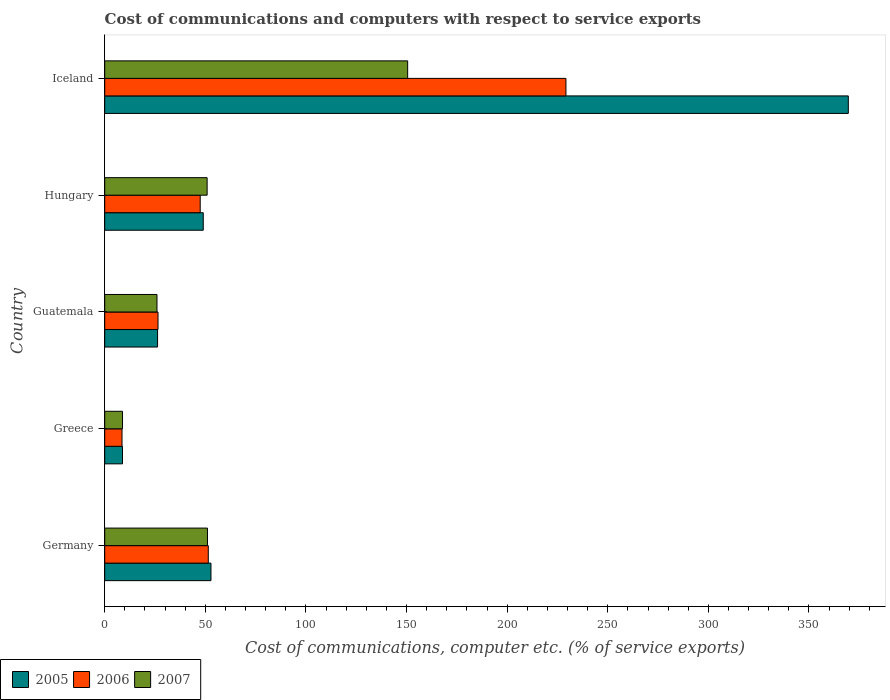How many different coloured bars are there?
Offer a very short reply. 3. Are the number of bars per tick equal to the number of legend labels?
Give a very brief answer. Yes. Are the number of bars on each tick of the Y-axis equal?
Provide a succinct answer. Yes. How many bars are there on the 2nd tick from the top?
Make the answer very short. 3. How many bars are there on the 5th tick from the bottom?
Make the answer very short. 3. What is the label of the 5th group of bars from the top?
Offer a terse response. Germany. What is the cost of communications and computers in 2007 in Guatemala?
Offer a terse response. 25.98. Across all countries, what is the maximum cost of communications and computers in 2007?
Your answer should be compact. 150.55. Across all countries, what is the minimum cost of communications and computers in 2005?
Keep it short and to the point. 8.84. In which country was the cost of communications and computers in 2006 maximum?
Your answer should be compact. Iceland. In which country was the cost of communications and computers in 2007 minimum?
Offer a terse response. Greece. What is the total cost of communications and computers in 2006 in the graph?
Provide a short and direct response. 363.22. What is the difference between the cost of communications and computers in 2005 in Guatemala and that in Iceland?
Give a very brief answer. -343.28. What is the difference between the cost of communications and computers in 2007 in Guatemala and the cost of communications and computers in 2006 in Germany?
Provide a short and direct response. -25.49. What is the average cost of communications and computers in 2006 per country?
Your answer should be compact. 72.64. What is the difference between the cost of communications and computers in 2005 and cost of communications and computers in 2006 in Hungary?
Ensure brevity in your answer.  1.51. What is the ratio of the cost of communications and computers in 2006 in Guatemala to that in Hungary?
Your answer should be very brief. 0.56. Is the cost of communications and computers in 2006 in Germany less than that in Hungary?
Your response must be concise. No. What is the difference between the highest and the second highest cost of communications and computers in 2007?
Provide a succinct answer. 99.49. What is the difference between the highest and the lowest cost of communications and computers in 2006?
Provide a short and direct response. 220.61. In how many countries, is the cost of communications and computers in 2007 greater than the average cost of communications and computers in 2007 taken over all countries?
Make the answer very short. 1. Is it the case that in every country, the sum of the cost of communications and computers in 2005 and cost of communications and computers in 2007 is greater than the cost of communications and computers in 2006?
Offer a terse response. Yes. How many bars are there?
Provide a succinct answer. 15. Are the values on the major ticks of X-axis written in scientific E-notation?
Offer a terse response. No. Does the graph contain grids?
Your response must be concise. No. Where does the legend appear in the graph?
Give a very brief answer. Bottom left. How many legend labels are there?
Provide a short and direct response. 3. What is the title of the graph?
Your answer should be very brief. Cost of communications and computers with respect to service exports. Does "1967" appear as one of the legend labels in the graph?
Keep it short and to the point. No. What is the label or title of the X-axis?
Your answer should be compact. Cost of communications, computer etc. (% of service exports). What is the label or title of the Y-axis?
Keep it short and to the point. Country. What is the Cost of communications, computer etc. (% of service exports) of 2005 in Germany?
Your response must be concise. 52.8. What is the Cost of communications, computer etc. (% of service exports) of 2006 in Germany?
Your answer should be compact. 51.47. What is the Cost of communications, computer etc. (% of service exports) in 2007 in Germany?
Make the answer very short. 51.06. What is the Cost of communications, computer etc. (% of service exports) in 2005 in Greece?
Your answer should be compact. 8.84. What is the Cost of communications, computer etc. (% of service exports) of 2006 in Greece?
Provide a short and direct response. 8.6. What is the Cost of communications, computer etc. (% of service exports) in 2007 in Greece?
Give a very brief answer. 8.84. What is the Cost of communications, computer etc. (% of service exports) in 2005 in Guatemala?
Offer a very short reply. 26.27. What is the Cost of communications, computer etc. (% of service exports) of 2006 in Guatemala?
Offer a very short reply. 26.49. What is the Cost of communications, computer etc. (% of service exports) of 2007 in Guatemala?
Provide a short and direct response. 25.98. What is the Cost of communications, computer etc. (% of service exports) of 2005 in Hungary?
Give a very brief answer. 48.97. What is the Cost of communications, computer etc. (% of service exports) in 2006 in Hungary?
Your response must be concise. 47.45. What is the Cost of communications, computer etc. (% of service exports) in 2007 in Hungary?
Your response must be concise. 50.89. What is the Cost of communications, computer etc. (% of service exports) in 2005 in Iceland?
Make the answer very short. 369.54. What is the Cost of communications, computer etc. (% of service exports) in 2006 in Iceland?
Provide a short and direct response. 229.21. What is the Cost of communications, computer etc. (% of service exports) of 2007 in Iceland?
Keep it short and to the point. 150.55. Across all countries, what is the maximum Cost of communications, computer etc. (% of service exports) of 2005?
Give a very brief answer. 369.54. Across all countries, what is the maximum Cost of communications, computer etc. (% of service exports) in 2006?
Give a very brief answer. 229.21. Across all countries, what is the maximum Cost of communications, computer etc. (% of service exports) of 2007?
Your answer should be very brief. 150.55. Across all countries, what is the minimum Cost of communications, computer etc. (% of service exports) in 2005?
Your response must be concise. 8.84. Across all countries, what is the minimum Cost of communications, computer etc. (% of service exports) in 2006?
Offer a very short reply. 8.6. Across all countries, what is the minimum Cost of communications, computer etc. (% of service exports) of 2007?
Give a very brief answer. 8.84. What is the total Cost of communications, computer etc. (% of service exports) of 2005 in the graph?
Keep it short and to the point. 506.42. What is the total Cost of communications, computer etc. (% of service exports) of 2006 in the graph?
Make the answer very short. 363.22. What is the total Cost of communications, computer etc. (% of service exports) of 2007 in the graph?
Your answer should be very brief. 287.32. What is the difference between the Cost of communications, computer etc. (% of service exports) in 2005 in Germany and that in Greece?
Make the answer very short. 43.96. What is the difference between the Cost of communications, computer etc. (% of service exports) in 2006 in Germany and that in Greece?
Offer a very short reply. 42.87. What is the difference between the Cost of communications, computer etc. (% of service exports) in 2007 in Germany and that in Greece?
Your answer should be very brief. 42.22. What is the difference between the Cost of communications, computer etc. (% of service exports) of 2005 in Germany and that in Guatemala?
Offer a terse response. 26.54. What is the difference between the Cost of communications, computer etc. (% of service exports) in 2006 in Germany and that in Guatemala?
Offer a very short reply. 24.98. What is the difference between the Cost of communications, computer etc. (% of service exports) of 2007 in Germany and that in Guatemala?
Ensure brevity in your answer.  25.09. What is the difference between the Cost of communications, computer etc. (% of service exports) of 2005 in Germany and that in Hungary?
Your answer should be very brief. 3.84. What is the difference between the Cost of communications, computer etc. (% of service exports) of 2006 in Germany and that in Hungary?
Give a very brief answer. 4.01. What is the difference between the Cost of communications, computer etc. (% of service exports) in 2007 in Germany and that in Hungary?
Provide a succinct answer. 0.17. What is the difference between the Cost of communications, computer etc. (% of service exports) in 2005 in Germany and that in Iceland?
Your response must be concise. -316.74. What is the difference between the Cost of communications, computer etc. (% of service exports) of 2006 in Germany and that in Iceland?
Your answer should be very brief. -177.74. What is the difference between the Cost of communications, computer etc. (% of service exports) of 2007 in Germany and that in Iceland?
Offer a very short reply. -99.49. What is the difference between the Cost of communications, computer etc. (% of service exports) in 2005 in Greece and that in Guatemala?
Provide a short and direct response. -17.42. What is the difference between the Cost of communications, computer etc. (% of service exports) of 2006 in Greece and that in Guatemala?
Give a very brief answer. -17.89. What is the difference between the Cost of communications, computer etc. (% of service exports) of 2007 in Greece and that in Guatemala?
Your answer should be very brief. -17.13. What is the difference between the Cost of communications, computer etc. (% of service exports) of 2005 in Greece and that in Hungary?
Your answer should be compact. -40.13. What is the difference between the Cost of communications, computer etc. (% of service exports) of 2006 in Greece and that in Hungary?
Provide a short and direct response. -38.86. What is the difference between the Cost of communications, computer etc. (% of service exports) in 2007 in Greece and that in Hungary?
Offer a terse response. -42.05. What is the difference between the Cost of communications, computer etc. (% of service exports) of 2005 in Greece and that in Iceland?
Keep it short and to the point. -360.7. What is the difference between the Cost of communications, computer etc. (% of service exports) of 2006 in Greece and that in Iceland?
Provide a succinct answer. -220.61. What is the difference between the Cost of communications, computer etc. (% of service exports) in 2007 in Greece and that in Iceland?
Make the answer very short. -141.71. What is the difference between the Cost of communications, computer etc. (% of service exports) in 2005 in Guatemala and that in Hungary?
Keep it short and to the point. -22.7. What is the difference between the Cost of communications, computer etc. (% of service exports) of 2006 in Guatemala and that in Hungary?
Your response must be concise. -20.97. What is the difference between the Cost of communications, computer etc. (% of service exports) of 2007 in Guatemala and that in Hungary?
Provide a succinct answer. -24.91. What is the difference between the Cost of communications, computer etc. (% of service exports) in 2005 in Guatemala and that in Iceland?
Ensure brevity in your answer.  -343.28. What is the difference between the Cost of communications, computer etc. (% of service exports) in 2006 in Guatemala and that in Iceland?
Provide a short and direct response. -202.72. What is the difference between the Cost of communications, computer etc. (% of service exports) in 2007 in Guatemala and that in Iceland?
Provide a short and direct response. -124.58. What is the difference between the Cost of communications, computer etc. (% of service exports) in 2005 in Hungary and that in Iceland?
Keep it short and to the point. -320.58. What is the difference between the Cost of communications, computer etc. (% of service exports) of 2006 in Hungary and that in Iceland?
Provide a short and direct response. -181.76. What is the difference between the Cost of communications, computer etc. (% of service exports) in 2007 in Hungary and that in Iceland?
Provide a short and direct response. -99.66. What is the difference between the Cost of communications, computer etc. (% of service exports) in 2005 in Germany and the Cost of communications, computer etc. (% of service exports) in 2006 in Greece?
Your response must be concise. 44.2. What is the difference between the Cost of communications, computer etc. (% of service exports) of 2005 in Germany and the Cost of communications, computer etc. (% of service exports) of 2007 in Greece?
Ensure brevity in your answer.  43.96. What is the difference between the Cost of communications, computer etc. (% of service exports) of 2006 in Germany and the Cost of communications, computer etc. (% of service exports) of 2007 in Greece?
Ensure brevity in your answer.  42.63. What is the difference between the Cost of communications, computer etc. (% of service exports) in 2005 in Germany and the Cost of communications, computer etc. (% of service exports) in 2006 in Guatemala?
Keep it short and to the point. 26.32. What is the difference between the Cost of communications, computer etc. (% of service exports) in 2005 in Germany and the Cost of communications, computer etc. (% of service exports) in 2007 in Guatemala?
Your answer should be compact. 26.83. What is the difference between the Cost of communications, computer etc. (% of service exports) of 2006 in Germany and the Cost of communications, computer etc. (% of service exports) of 2007 in Guatemala?
Your answer should be very brief. 25.49. What is the difference between the Cost of communications, computer etc. (% of service exports) of 2005 in Germany and the Cost of communications, computer etc. (% of service exports) of 2006 in Hungary?
Offer a terse response. 5.35. What is the difference between the Cost of communications, computer etc. (% of service exports) in 2005 in Germany and the Cost of communications, computer etc. (% of service exports) in 2007 in Hungary?
Provide a short and direct response. 1.91. What is the difference between the Cost of communications, computer etc. (% of service exports) in 2006 in Germany and the Cost of communications, computer etc. (% of service exports) in 2007 in Hungary?
Offer a terse response. 0.58. What is the difference between the Cost of communications, computer etc. (% of service exports) of 2005 in Germany and the Cost of communications, computer etc. (% of service exports) of 2006 in Iceland?
Your answer should be very brief. -176.41. What is the difference between the Cost of communications, computer etc. (% of service exports) of 2005 in Germany and the Cost of communications, computer etc. (% of service exports) of 2007 in Iceland?
Your response must be concise. -97.75. What is the difference between the Cost of communications, computer etc. (% of service exports) of 2006 in Germany and the Cost of communications, computer etc. (% of service exports) of 2007 in Iceland?
Ensure brevity in your answer.  -99.09. What is the difference between the Cost of communications, computer etc. (% of service exports) of 2005 in Greece and the Cost of communications, computer etc. (% of service exports) of 2006 in Guatemala?
Your answer should be compact. -17.65. What is the difference between the Cost of communications, computer etc. (% of service exports) in 2005 in Greece and the Cost of communications, computer etc. (% of service exports) in 2007 in Guatemala?
Ensure brevity in your answer.  -17.14. What is the difference between the Cost of communications, computer etc. (% of service exports) of 2006 in Greece and the Cost of communications, computer etc. (% of service exports) of 2007 in Guatemala?
Give a very brief answer. -17.38. What is the difference between the Cost of communications, computer etc. (% of service exports) in 2005 in Greece and the Cost of communications, computer etc. (% of service exports) in 2006 in Hungary?
Give a very brief answer. -38.61. What is the difference between the Cost of communications, computer etc. (% of service exports) in 2005 in Greece and the Cost of communications, computer etc. (% of service exports) in 2007 in Hungary?
Make the answer very short. -42.05. What is the difference between the Cost of communications, computer etc. (% of service exports) of 2006 in Greece and the Cost of communications, computer etc. (% of service exports) of 2007 in Hungary?
Provide a succinct answer. -42.29. What is the difference between the Cost of communications, computer etc. (% of service exports) of 2005 in Greece and the Cost of communications, computer etc. (% of service exports) of 2006 in Iceland?
Your response must be concise. -220.37. What is the difference between the Cost of communications, computer etc. (% of service exports) in 2005 in Greece and the Cost of communications, computer etc. (% of service exports) in 2007 in Iceland?
Give a very brief answer. -141.71. What is the difference between the Cost of communications, computer etc. (% of service exports) in 2006 in Greece and the Cost of communications, computer etc. (% of service exports) in 2007 in Iceland?
Your answer should be very brief. -141.96. What is the difference between the Cost of communications, computer etc. (% of service exports) in 2005 in Guatemala and the Cost of communications, computer etc. (% of service exports) in 2006 in Hungary?
Provide a short and direct response. -21.19. What is the difference between the Cost of communications, computer etc. (% of service exports) in 2005 in Guatemala and the Cost of communications, computer etc. (% of service exports) in 2007 in Hungary?
Your answer should be compact. -24.62. What is the difference between the Cost of communications, computer etc. (% of service exports) in 2006 in Guatemala and the Cost of communications, computer etc. (% of service exports) in 2007 in Hungary?
Provide a short and direct response. -24.4. What is the difference between the Cost of communications, computer etc. (% of service exports) of 2005 in Guatemala and the Cost of communications, computer etc. (% of service exports) of 2006 in Iceland?
Ensure brevity in your answer.  -202.95. What is the difference between the Cost of communications, computer etc. (% of service exports) of 2005 in Guatemala and the Cost of communications, computer etc. (% of service exports) of 2007 in Iceland?
Your answer should be very brief. -124.29. What is the difference between the Cost of communications, computer etc. (% of service exports) of 2006 in Guatemala and the Cost of communications, computer etc. (% of service exports) of 2007 in Iceland?
Your answer should be compact. -124.07. What is the difference between the Cost of communications, computer etc. (% of service exports) of 2005 in Hungary and the Cost of communications, computer etc. (% of service exports) of 2006 in Iceland?
Your answer should be very brief. -180.25. What is the difference between the Cost of communications, computer etc. (% of service exports) in 2005 in Hungary and the Cost of communications, computer etc. (% of service exports) in 2007 in Iceland?
Your answer should be compact. -101.59. What is the difference between the Cost of communications, computer etc. (% of service exports) of 2006 in Hungary and the Cost of communications, computer etc. (% of service exports) of 2007 in Iceland?
Your response must be concise. -103.1. What is the average Cost of communications, computer etc. (% of service exports) in 2005 per country?
Provide a succinct answer. 101.28. What is the average Cost of communications, computer etc. (% of service exports) in 2006 per country?
Your answer should be very brief. 72.64. What is the average Cost of communications, computer etc. (% of service exports) of 2007 per country?
Give a very brief answer. 57.46. What is the difference between the Cost of communications, computer etc. (% of service exports) in 2005 and Cost of communications, computer etc. (% of service exports) in 2006 in Germany?
Provide a succinct answer. 1.33. What is the difference between the Cost of communications, computer etc. (% of service exports) of 2005 and Cost of communications, computer etc. (% of service exports) of 2007 in Germany?
Keep it short and to the point. 1.74. What is the difference between the Cost of communications, computer etc. (% of service exports) in 2006 and Cost of communications, computer etc. (% of service exports) in 2007 in Germany?
Offer a very short reply. 0.4. What is the difference between the Cost of communications, computer etc. (% of service exports) in 2005 and Cost of communications, computer etc. (% of service exports) in 2006 in Greece?
Your answer should be compact. 0.24. What is the difference between the Cost of communications, computer etc. (% of service exports) in 2005 and Cost of communications, computer etc. (% of service exports) in 2007 in Greece?
Offer a very short reply. -0. What is the difference between the Cost of communications, computer etc. (% of service exports) of 2006 and Cost of communications, computer etc. (% of service exports) of 2007 in Greece?
Your answer should be very brief. -0.24. What is the difference between the Cost of communications, computer etc. (% of service exports) of 2005 and Cost of communications, computer etc. (% of service exports) of 2006 in Guatemala?
Provide a short and direct response. -0.22. What is the difference between the Cost of communications, computer etc. (% of service exports) of 2005 and Cost of communications, computer etc. (% of service exports) of 2007 in Guatemala?
Provide a succinct answer. 0.29. What is the difference between the Cost of communications, computer etc. (% of service exports) of 2006 and Cost of communications, computer etc. (% of service exports) of 2007 in Guatemala?
Offer a very short reply. 0.51. What is the difference between the Cost of communications, computer etc. (% of service exports) of 2005 and Cost of communications, computer etc. (% of service exports) of 2006 in Hungary?
Your response must be concise. 1.51. What is the difference between the Cost of communications, computer etc. (% of service exports) of 2005 and Cost of communications, computer etc. (% of service exports) of 2007 in Hungary?
Ensure brevity in your answer.  -1.92. What is the difference between the Cost of communications, computer etc. (% of service exports) of 2006 and Cost of communications, computer etc. (% of service exports) of 2007 in Hungary?
Give a very brief answer. -3.44. What is the difference between the Cost of communications, computer etc. (% of service exports) of 2005 and Cost of communications, computer etc. (% of service exports) of 2006 in Iceland?
Ensure brevity in your answer.  140.33. What is the difference between the Cost of communications, computer etc. (% of service exports) in 2005 and Cost of communications, computer etc. (% of service exports) in 2007 in Iceland?
Offer a very short reply. 218.99. What is the difference between the Cost of communications, computer etc. (% of service exports) of 2006 and Cost of communications, computer etc. (% of service exports) of 2007 in Iceland?
Your answer should be very brief. 78.66. What is the ratio of the Cost of communications, computer etc. (% of service exports) in 2005 in Germany to that in Greece?
Ensure brevity in your answer.  5.97. What is the ratio of the Cost of communications, computer etc. (% of service exports) of 2006 in Germany to that in Greece?
Your answer should be compact. 5.99. What is the ratio of the Cost of communications, computer etc. (% of service exports) in 2007 in Germany to that in Greece?
Give a very brief answer. 5.78. What is the ratio of the Cost of communications, computer etc. (% of service exports) of 2005 in Germany to that in Guatemala?
Your response must be concise. 2.01. What is the ratio of the Cost of communications, computer etc. (% of service exports) of 2006 in Germany to that in Guatemala?
Make the answer very short. 1.94. What is the ratio of the Cost of communications, computer etc. (% of service exports) of 2007 in Germany to that in Guatemala?
Make the answer very short. 1.97. What is the ratio of the Cost of communications, computer etc. (% of service exports) in 2005 in Germany to that in Hungary?
Keep it short and to the point. 1.08. What is the ratio of the Cost of communications, computer etc. (% of service exports) in 2006 in Germany to that in Hungary?
Provide a short and direct response. 1.08. What is the ratio of the Cost of communications, computer etc. (% of service exports) in 2005 in Germany to that in Iceland?
Your answer should be very brief. 0.14. What is the ratio of the Cost of communications, computer etc. (% of service exports) of 2006 in Germany to that in Iceland?
Provide a short and direct response. 0.22. What is the ratio of the Cost of communications, computer etc. (% of service exports) of 2007 in Germany to that in Iceland?
Offer a terse response. 0.34. What is the ratio of the Cost of communications, computer etc. (% of service exports) in 2005 in Greece to that in Guatemala?
Your response must be concise. 0.34. What is the ratio of the Cost of communications, computer etc. (% of service exports) in 2006 in Greece to that in Guatemala?
Your answer should be very brief. 0.32. What is the ratio of the Cost of communications, computer etc. (% of service exports) in 2007 in Greece to that in Guatemala?
Provide a short and direct response. 0.34. What is the ratio of the Cost of communications, computer etc. (% of service exports) of 2005 in Greece to that in Hungary?
Make the answer very short. 0.18. What is the ratio of the Cost of communications, computer etc. (% of service exports) in 2006 in Greece to that in Hungary?
Offer a very short reply. 0.18. What is the ratio of the Cost of communications, computer etc. (% of service exports) of 2007 in Greece to that in Hungary?
Your response must be concise. 0.17. What is the ratio of the Cost of communications, computer etc. (% of service exports) in 2005 in Greece to that in Iceland?
Provide a succinct answer. 0.02. What is the ratio of the Cost of communications, computer etc. (% of service exports) of 2006 in Greece to that in Iceland?
Provide a succinct answer. 0.04. What is the ratio of the Cost of communications, computer etc. (% of service exports) in 2007 in Greece to that in Iceland?
Provide a short and direct response. 0.06. What is the ratio of the Cost of communications, computer etc. (% of service exports) of 2005 in Guatemala to that in Hungary?
Make the answer very short. 0.54. What is the ratio of the Cost of communications, computer etc. (% of service exports) in 2006 in Guatemala to that in Hungary?
Make the answer very short. 0.56. What is the ratio of the Cost of communications, computer etc. (% of service exports) in 2007 in Guatemala to that in Hungary?
Ensure brevity in your answer.  0.51. What is the ratio of the Cost of communications, computer etc. (% of service exports) in 2005 in Guatemala to that in Iceland?
Provide a succinct answer. 0.07. What is the ratio of the Cost of communications, computer etc. (% of service exports) in 2006 in Guatemala to that in Iceland?
Ensure brevity in your answer.  0.12. What is the ratio of the Cost of communications, computer etc. (% of service exports) of 2007 in Guatemala to that in Iceland?
Give a very brief answer. 0.17. What is the ratio of the Cost of communications, computer etc. (% of service exports) in 2005 in Hungary to that in Iceland?
Make the answer very short. 0.13. What is the ratio of the Cost of communications, computer etc. (% of service exports) of 2006 in Hungary to that in Iceland?
Offer a very short reply. 0.21. What is the ratio of the Cost of communications, computer etc. (% of service exports) in 2007 in Hungary to that in Iceland?
Offer a very short reply. 0.34. What is the difference between the highest and the second highest Cost of communications, computer etc. (% of service exports) of 2005?
Ensure brevity in your answer.  316.74. What is the difference between the highest and the second highest Cost of communications, computer etc. (% of service exports) in 2006?
Ensure brevity in your answer.  177.74. What is the difference between the highest and the second highest Cost of communications, computer etc. (% of service exports) of 2007?
Offer a terse response. 99.49. What is the difference between the highest and the lowest Cost of communications, computer etc. (% of service exports) in 2005?
Your response must be concise. 360.7. What is the difference between the highest and the lowest Cost of communications, computer etc. (% of service exports) of 2006?
Your response must be concise. 220.61. What is the difference between the highest and the lowest Cost of communications, computer etc. (% of service exports) in 2007?
Your answer should be very brief. 141.71. 